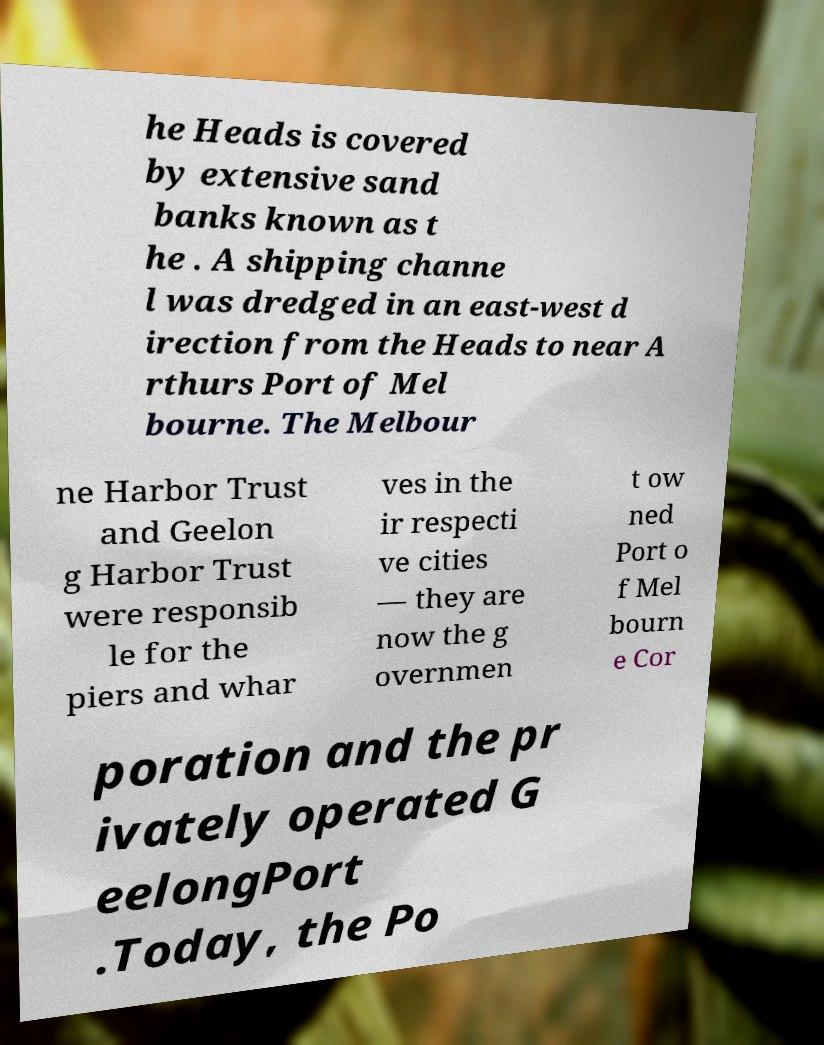For documentation purposes, I need the text within this image transcribed. Could you provide that? he Heads is covered by extensive sand banks known as t he . A shipping channe l was dredged in an east-west d irection from the Heads to near A rthurs Port of Mel bourne. The Melbour ne Harbor Trust and Geelon g Harbor Trust were responsib le for the piers and whar ves in the ir respecti ve cities — they are now the g overnmen t ow ned Port o f Mel bourn e Cor poration and the pr ivately operated G eelongPort .Today, the Po 